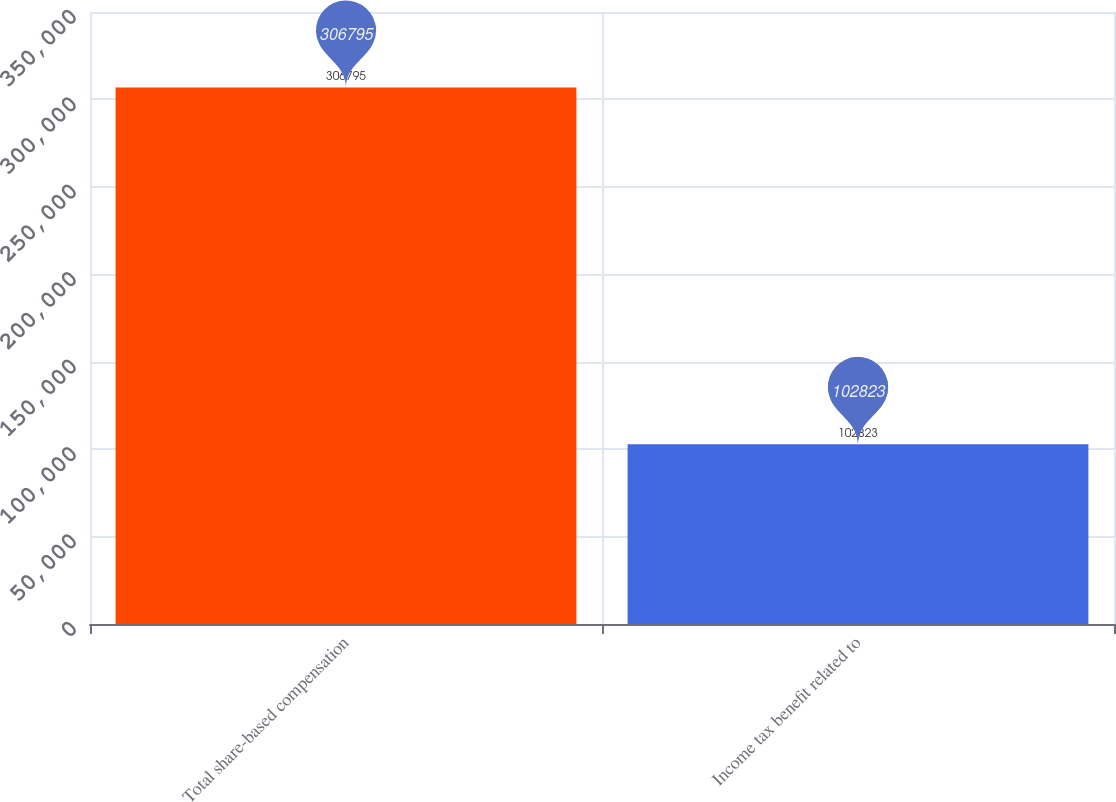Convert chart to OTSL. <chart><loc_0><loc_0><loc_500><loc_500><bar_chart><fcel>Total share-based compensation<fcel>Income tax benefit related to<nl><fcel>306795<fcel>102823<nl></chart> 